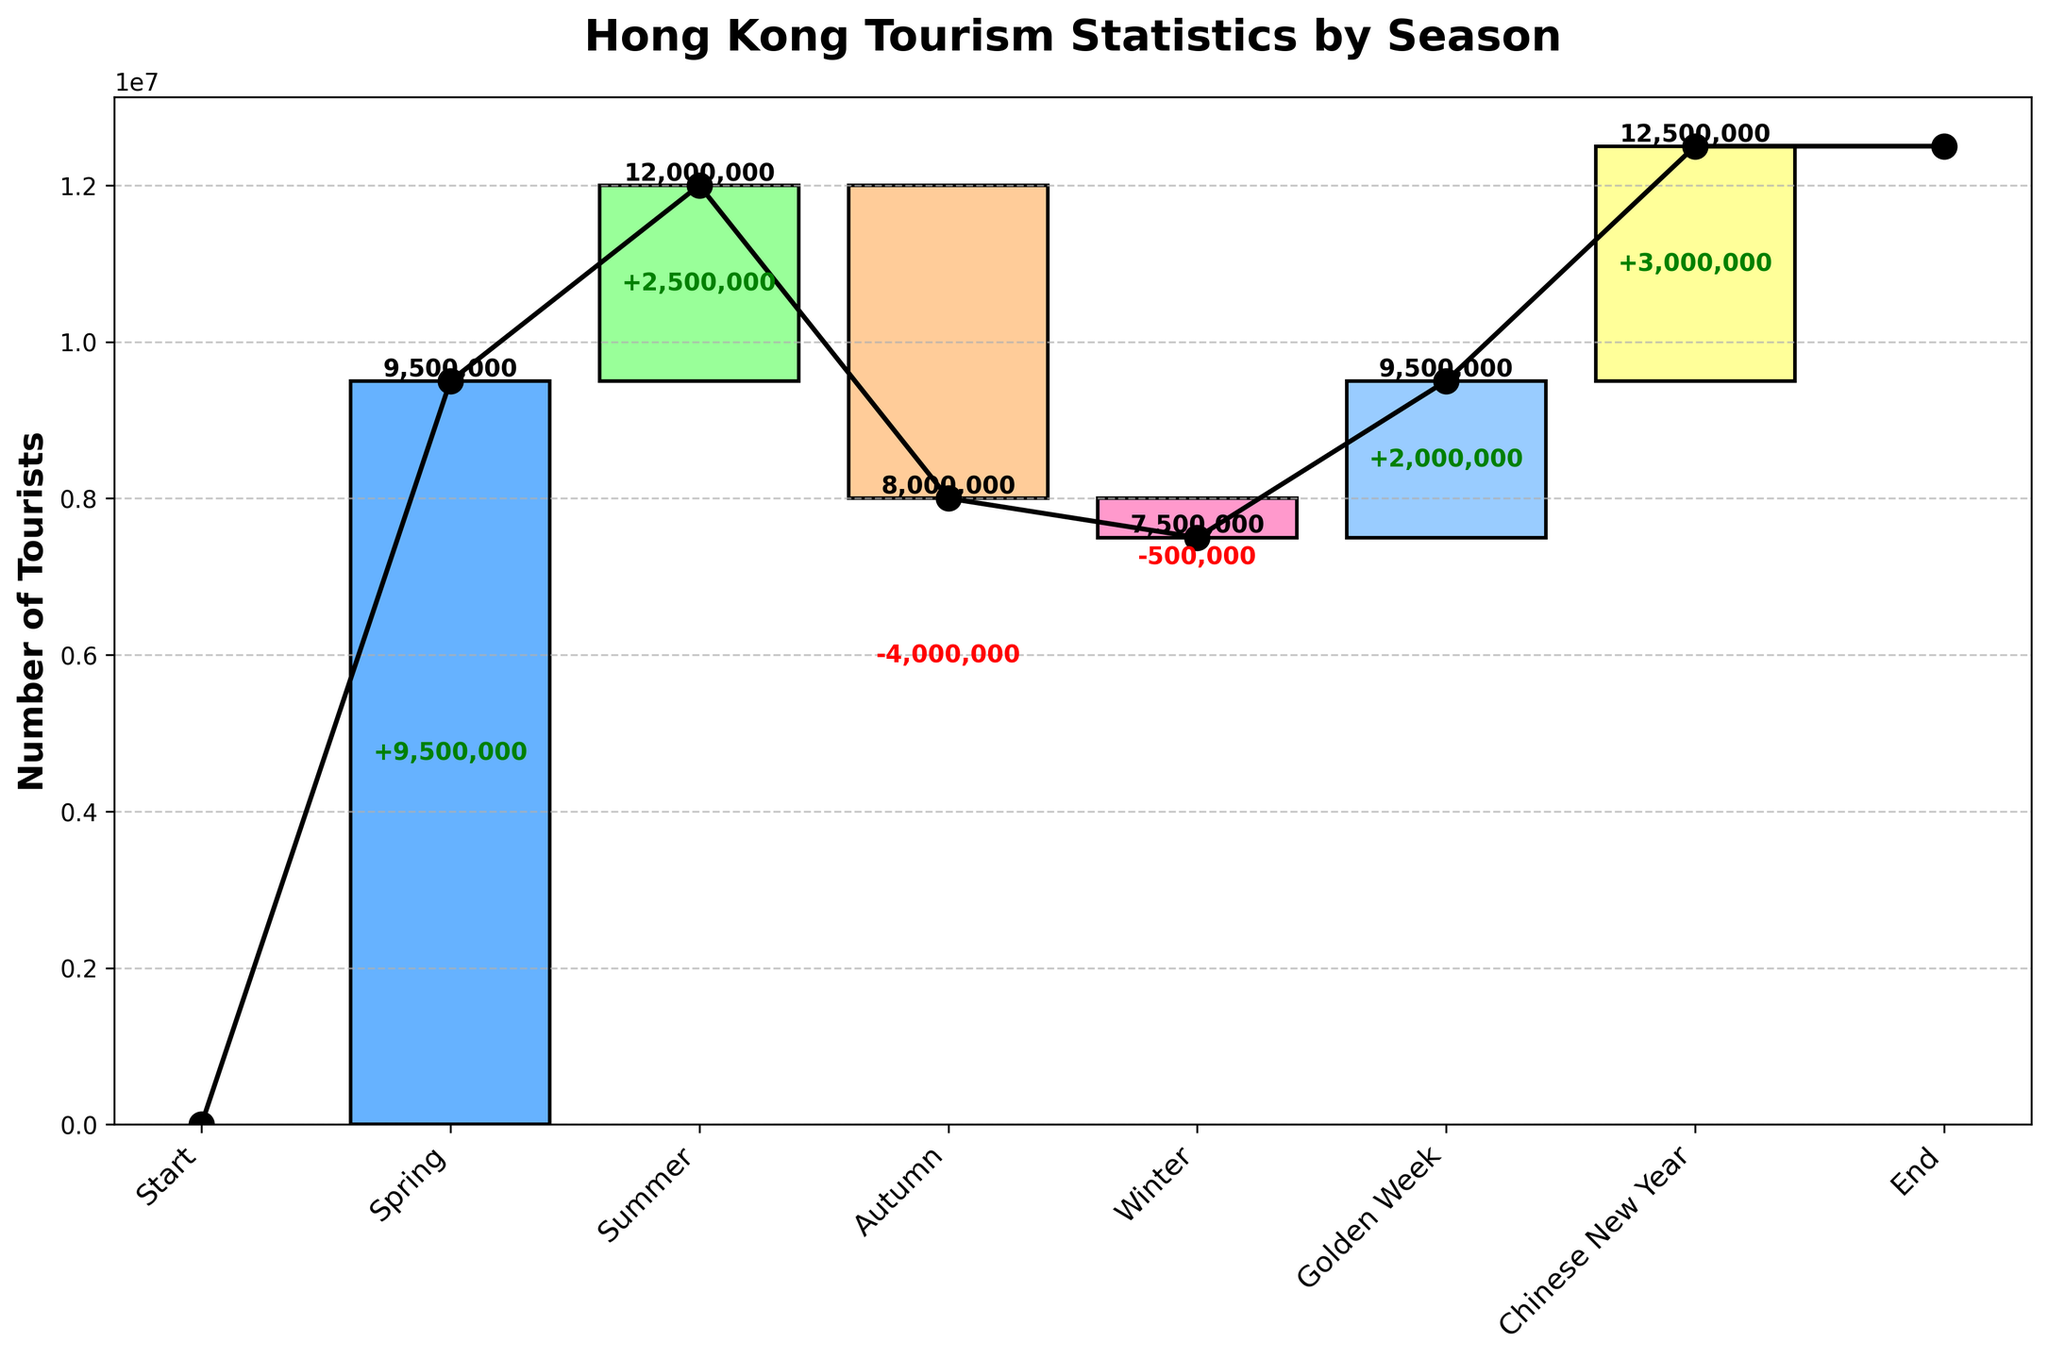What's the title of the figure? The title of the figure is located at the top of the plot. It is written in a bold font and larger text size.
Answer: Hong Kong Tourism Statistics by Season How many seasons are mentioned in the figure? The number of seasons is derived from the x-axis, which lists unique labels for each of the categories represented.
Answer: 8 Which season shows the highest increase in tourists? To identify this, observe the height of the positive bars. The tallest positive bar corresponds to the largest increase.
Answer: Summer Which season experiences the largest decrease in tourists? To find the largest decrease, look for the tallest negative bar. This represents the largest drop in tourist numbers.
Answer: Autumn What is the total number of tourists by the end of the year? Look for the figure at the end of the cumulative line. This gives the total accumulated number.
Answer: 37,000,000 By how much did the tourist numbers increase during Golden Week? To determine this, find the difference for the specific bar labeled "Golden Week."
Answer: 2,000,000 How does the number of tourists change from Summer to Autumn? Calculate the difference shown by the bars from Summer to Autumn. Summer shows an increase while Autumn shows a decrease next to it.
Answer: Decrease by 4,000,000 Which period contributed the least to the overall tourist numbers? Compare the height of all the bars. The shortest bar corresponds to the least contribution.
Answer: Winter What is the cumulative number of tourists by the end of Spring? Sum the tourist numbers up to the end of the Spring season, following the cumulative line.
Answer: 9,500,000 How many seasons contributed to an increase in tourist numbers? Count the number of bars that are positive (colored above the baseline). This represents an increase.
Answer: 4 (Spring, Summer, Golden Week, Chinese New Year) 